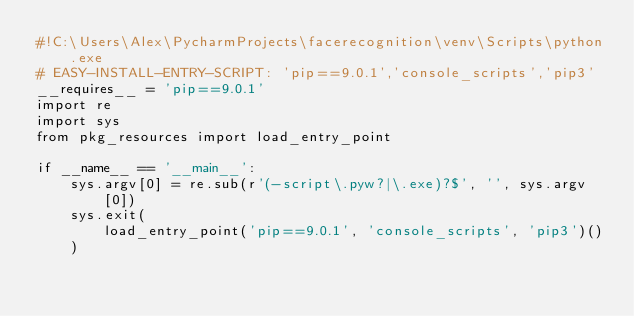Convert code to text. <code><loc_0><loc_0><loc_500><loc_500><_Python_>#!C:\Users\Alex\PycharmProjects\facerecognition\venv\Scripts\python.exe
# EASY-INSTALL-ENTRY-SCRIPT: 'pip==9.0.1','console_scripts','pip3'
__requires__ = 'pip==9.0.1'
import re
import sys
from pkg_resources import load_entry_point

if __name__ == '__main__':
    sys.argv[0] = re.sub(r'(-script\.pyw?|\.exe)?$', '', sys.argv[0])
    sys.exit(
        load_entry_point('pip==9.0.1', 'console_scripts', 'pip3')()
    )
</code> 